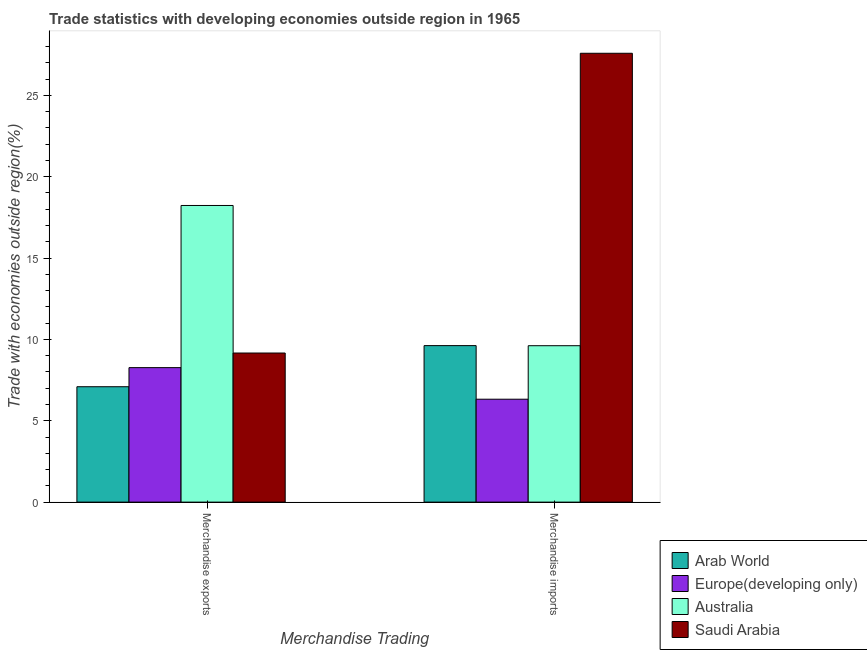How many groups of bars are there?
Your response must be concise. 2. Are the number of bars per tick equal to the number of legend labels?
Offer a terse response. Yes. Are the number of bars on each tick of the X-axis equal?
Your response must be concise. Yes. How many bars are there on the 2nd tick from the left?
Provide a succinct answer. 4. How many bars are there on the 2nd tick from the right?
Make the answer very short. 4. What is the label of the 1st group of bars from the left?
Your response must be concise. Merchandise exports. What is the merchandise exports in Europe(developing only)?
Your answer should be compact. 8.27. Across all countries, what is the maximum merchandise exports?
Your answer should be very brief. 18.23. Across all countries, what is the minimum merchandise imports?
Offer a very short reply. 6.32. In which country was the merchandise exports minimum?
Make the answer very short. Arab World. What is the total merchandise imports in the graph?
Offer a terse response. 53.14. What is the difference between the merchandise exports in Saudi Arabia and that in Europe(developing only)?
Offer a terse response. 0.9. What is the difference between the merchandise imports in Saudi Arabia and the merchandise exports in Australia?
Give a very brief answer. 9.35. What is the average merchandise exports per country?
Offer a very short reply. 10.69. What is the difference between the merchandise imports and merchandise exports in Australia?
Make the answer very short. -8.62. What is the ratio of the merchandise exports in Europe(developing only) to that in Saudi Arabia?
Your response must be concise. 0.9. In how many countries, is the merchandise imports greater than the average merchandise imports taken over all countries?
Offer a very short reply. 1. What does the 1st bar from the left in Merchandise exports represents?
Give a very brief answer. Arab World. What does the 3rd bar from the right in Merchandise exports represents?
Keep it short and to the point. Europe(developing only). Are all the bars in the graph horizontal?
Ensure brevity in your answer.  No. Where does the legend appear in the graph?
Your response must be concise. Bottom right. What is the title of the graph?
Ensure brevity in your answer.  Trade statistics with developing economies outside region in 1965. Does "Qatar" appear as one of the legend labels in the graph?
Make the answer very short. No. What is the label or title of the X-axis?
Ensure brevity in your answer.  Merchandise Trading. What is the label or title of the Y-axis?
Offer a very short reply. Trade with economies outside region(%). What is the Trade with economies outside region(%) of Arab World in Merchandise exports?
Your answer should be compact. 7.09. What is the Trade with economies outside region(%) of Europe(developing only) in Merchandise exports?
Your response must be concise. 8.27. What is the Trade with economies outside region(%) of Australia in Merchandise exports?
Offer a terse response. 18.23. What is the Trade with economies outside region(%) of Saudi Arabia in Merchandise exports?
Give a very brief answer. 9.16. What is the Trade with economies outside region(%) in Arab World in Merchandise imports?
Keep it short and to the point. 9.62. What is the Trade with economies outside region(%) in Europe(developing only) in Merchandise imports?
Provide a short and direct response. 6.32. What is the Trade with economies outside region(%) in Australia in Merchandise imports?
Keep it short and to the point. 9.61. What is the Trade with economies outside region(%) in Saudi Arabia in Merchandise imports?
Keep it short and to the point. 27.58. Across all Merchandise Trading, what is the maximum Trade with economies outside region(%) in Arab World?
Your answer should be very brief. 9.62. Across all Merchandise Trading, what is the maximum Trade with economies outside region(%) of Europe(developing only)?
Offer a very short reply. 8.27. Across all Merchandise Trading, what is the maximum Trade with economies outside region(%) in Australia?
Keep it short and to the point. 18.23. Across all Merchandise Trading, what is the maximum Trade with economies outside region(%) of Saudi Arabia?
Your answer should be compact. 27.58. Across all Merchandise Trading, what is the minimum Trade with economies outside region(%) in Arab World?
Your answer should be very brief. 7.09. Across all Merchandise Trading, what is the minimum Trade with economies outside region(%) of Europe(developing only)?
Your answer should be compact. 6.32. Across all Merchandise Trading, what is the minimum Trade with economies outside region(%) of Australia?
Your response must be concise. 9.61. Across all Merchandise Trading, what is the minimum Trade with economies outside region(%) of Saudi Arabia?
Provide a succinct answer. 9.16. What is the total Trade with economies outside region(%) of Arab World in the graph?
Make the answer very short. 16.71. What is the total Trade with economies outside region(%) in Europe(developing only) in the graph?
Your response must be concise. 14.59. What is the total Trade with economies outside region(%) of Australia in the graph?
Provide a succinct answer. 27.84. What is the total Trade with economies outside region(%) of Saudi Arabia in the graph?
Your response must be concise. 36.75. What is the difference between the Trade with economies outside region(%) of Arab World in Merchandise exports and that in Merchandise imports?
Make the answer very short. -2.53. What is the difference between the Trade with economies outside region(%) of Europe(developing only) in Merchandise exports and that in Merchandise imports?
Ensure brevity in your answer.  1.94. What is the difference between the Trade with economies outside region(%) in Australia in Merchandise exports and that in Merchandise imports?
Offer a terse response. 8.62. What is the difference between the Trade with economies outside region(%) of Saudi Arabia in Merchandise exports and that in Merchandise imports?
Give a very brief answer. -18.42. What is the difference between the Trade with economies outside region(%) of Arab World in Merchandise exports and the Trade with economies outside region(%) of Europe(developing only) in Merchandise imports?
Provide a succinct answer. 0.77. What is the difference between the Trade with economies outside region(%) in Arab World in Merchandise exports and the Trade with economies outside region(%) in Australia in Merchandise imports?
Keep it short and to the point. -2.52. What is the difference between the Trade with economies outside region(%) of Arab World in Merchandise exports and the Trade with economies outside region(%) of Saudi Arabia in Merchandise imports?
Ensure brevity in your answer.  -20.49. What is the difference between the Trade with economies outside region(%) of Europe(developing only) in Merchandise exports and the Trade with economies outside region(%) of Australia in Merchandise imports?
Provide a succinct answer. -1.35. What is the difference between the Trade with economies outside region(%) of Europe(developing only) in Merchandise exports and the Trade with economies outside region(%) of Saudi Arabia in Merchandise imports?
Provide a short and direct response. -19.32. What is the difference between the Trade with economies outside region(%) in Australia in Merchandise exports and the Trade with economies outside region(%) in Saudi Arabia in Merchandise imports?
Keep it short and to the point. -9.35. What is the average Trade with economies outside region(%) of Arab World per Merchandise Trading?
Provide a succinct answer. 8.35. What is the average Trade with economies outside region(%) in Europe(developing only) per Merchandise Trading?
Your response must be concise. 7.29. What is the average Trade with economies outside region(%) in Australia per Merchandise Trading?
Your answer should be very brief. 13.92. What is the average Trade with economies outside region(%) in Saudi Arabia per Merchandise Trading?
Offer a terse response. 18.37. What is the difference between the Trade with economies outside region(%) of Arab World and Trade with economies outside region(%) of Europe(developing only) in Merchandise exports?
Your response must be concise. -1.17. What is the difference between the Trade with economies outside region(%) in Arab World and Trade with economies outside region(%) in Australia in Merchandise exports?
Provide a succinct answer. -11.14. What is the difference between the Trade with economies outside region(%) in Arab World and Trade with economies outside region(%) in Saudi Arabia in Merchandise exports?
Make the answer very short. -2.07. What is the difference between the Trade with economies outside region(%) of Europe(developing only) and Trade with economies outside region(%) of Australia in Merchandise exports?
Your answer should be compact. -9.97. What is the difference between the Trade with economies outside region(%) of Europe(developing only) and Trade with economies outside region(%) of Saudi Arabia in Merchandise exports?
Offer a very short reply. -0.9. What is the difference between the Trade with economies outside region(%) in Australia and Trade with economies outside region(%) in Saudi Arabia in Merchandise exports?
Your response must be concise. 9.07. What is the difference between the Trade with economies outside region(%) in Arab World and Trade with economies outside region(%) in Europe(developing only) in Merchandise imports?
Your answer should be compact. 3.29. What is the difference between the Trade with economies outside region(%) of Arab World and Trade with economies outside region(%) of Australia in Merchandise imports?
Your answer should be very brief. 0.01. What is the difference between the Trade with economies outside region(%) of Arab World and Trade with economies outside region(%) of Saudi Arabia in Merchandise imports?
Offer a terse response. -17.97. What is the difference between the Trade with economies outside region(%) in Europe(developing only) and Trade with economies outside region(%) in Australia in Merchandise imports?
Your answer should be compact. -3.29. What is the difference between the Trade with economies outside region(%) of Europe(developing only) and Trade with economies outside region(%) of Saudi Arabia in Merchandise imports?
Ensure brevity in your answer.  -21.26. What is the difference between the Trade with economies outside region(%) in Australia and Trade with economies outside region(%) in Saudi Arabia in Merchandise imports?
Give a very brief answer. -17.97. What is the ratio of the Trade with economies outside region(%) of Arab World in Merchandise exports to that in Merchandise imports?
Provide a short and direct response. 0.74. What is the ratio of the Trade with economies outside region(%) of Europe(developing only) in Merchandise exports to that in Merchandise imports?
Offer a terse response. 1.31. What is the ratio of the Trade with economies outside region(%) of Australia in Merchandise exports to that in Merchandise imports?
Offer a very short reply. 1.9. What is the ratio of the Trade with economies outside region(%) of Saudi Arabia in Merchandise exports to that in Merchandise imports?
Your answer should be very brief. 0.33. What is the difference between the highest and the second highest Trade with economies outside region(%) in Arab World?
Provide a short and direct response. 2.53. What is the difference between the highest and the second highest Trade with economies outside region(%) of Europe(developing only)?
Offer a very short reply. 1.94. What is the difference between the highest and the second highest Trade with economies outside region(%) of Australia?
Ensure brevity in your answer.  8.62. What is the difference between the highest and the second highest Trade with economies outside region(%) in Saudi Arabia?
Give a very brief answer. 18.42. What is the difference between the highest and the lowest Trade with economies outside region(%) of Arab World?
Make the answer very short. 2.53. What is the difference between the highest and the lowest Trade with economies outside region(%) of Europe(developing only)?
Give a very brief answer. 1.94. What is the difference between the highest and the lowest Trade with economies outside region(%) of Australia?
Give a very brief answer. 8.62. What is the difference between the highest and the lowest Trade with economies outside region(%) in Saudi Arabia?
Ensure brevity in your answer.  18.42. 